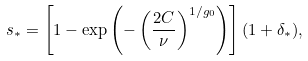<formula> <loc_0><loc_0><loc_500><loc_500>s _ { * } = \left [ 1 - \exp \left ( - \left ( \frac { 2 C } { \nu } \right ) ^ { 1 / g _ { 0 } } \right ) \right ] ( 1 + \delta _ { * } ) ,</formula> 